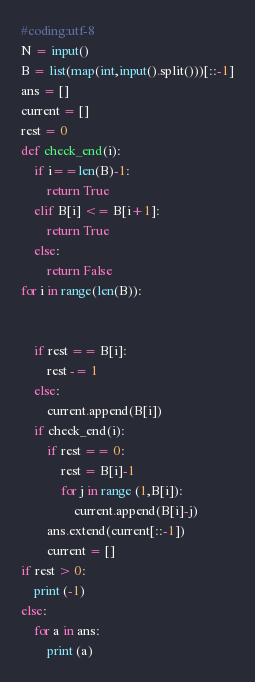<code> <loc_0><loc_0><loc_500><loc_500><_Python_>#coding:utf-8
N = input()
B = list(map(int,input().split()))[::-1]
ans = []
current = []
rest = 0
def check_end(i):
    if i==len(B)-1:
        return True
    elif B[i] <= B[i+1]:
        return True
    else:
        return False
for i in range(len(B)):


    if rest == B[i]:
        rest -= 1
    else:
        current.append(B[i])
    if check_end(i):
        if rest == 0:
            rest = B[i]-1
            for j in range (1,B[i]):
                current.append(B[i]-j)
        ans.extend(current[::-1])
        current = []
if rest > 0:
    print (-1)
else:
    for a in ans:    
        print (a)

</code> 